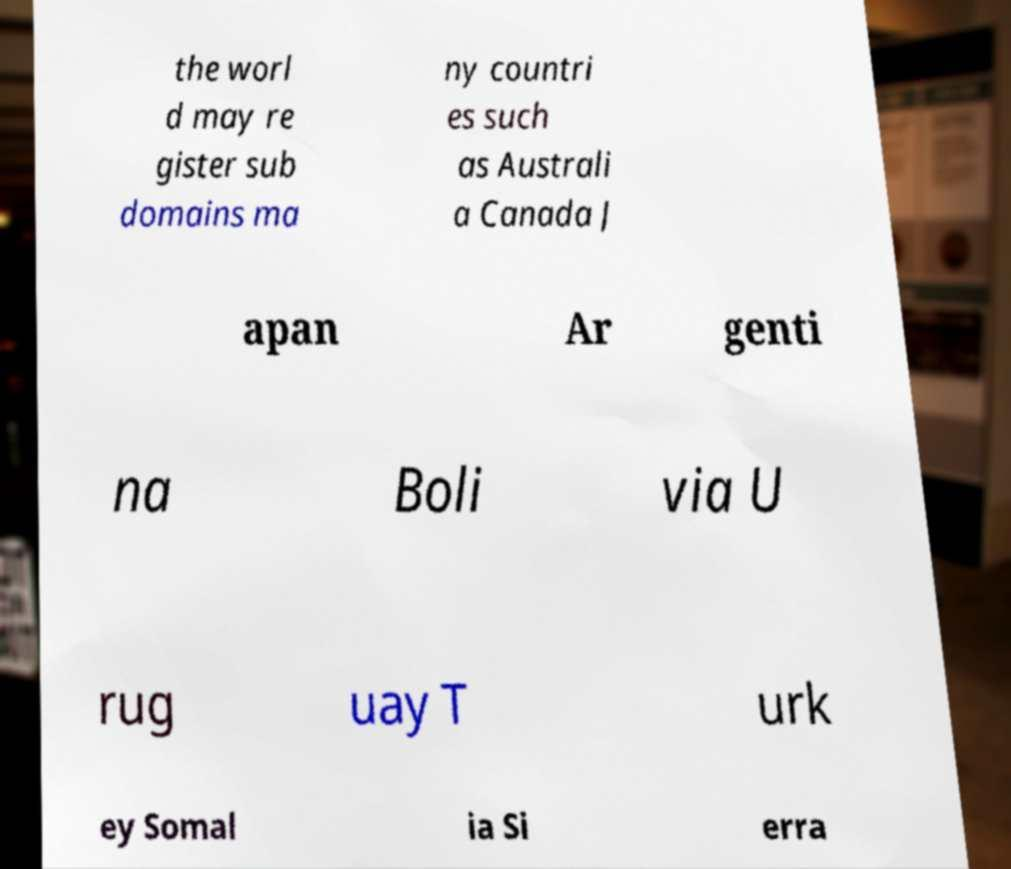For documentation purposes, I need the text within this image transcribed. Could you provide that? the worl d may re gister sub domains ma ny countri es such as Australi a Canada J apan Ar genti na Boli via U rug uay T urk ey Somal ia Si erra 